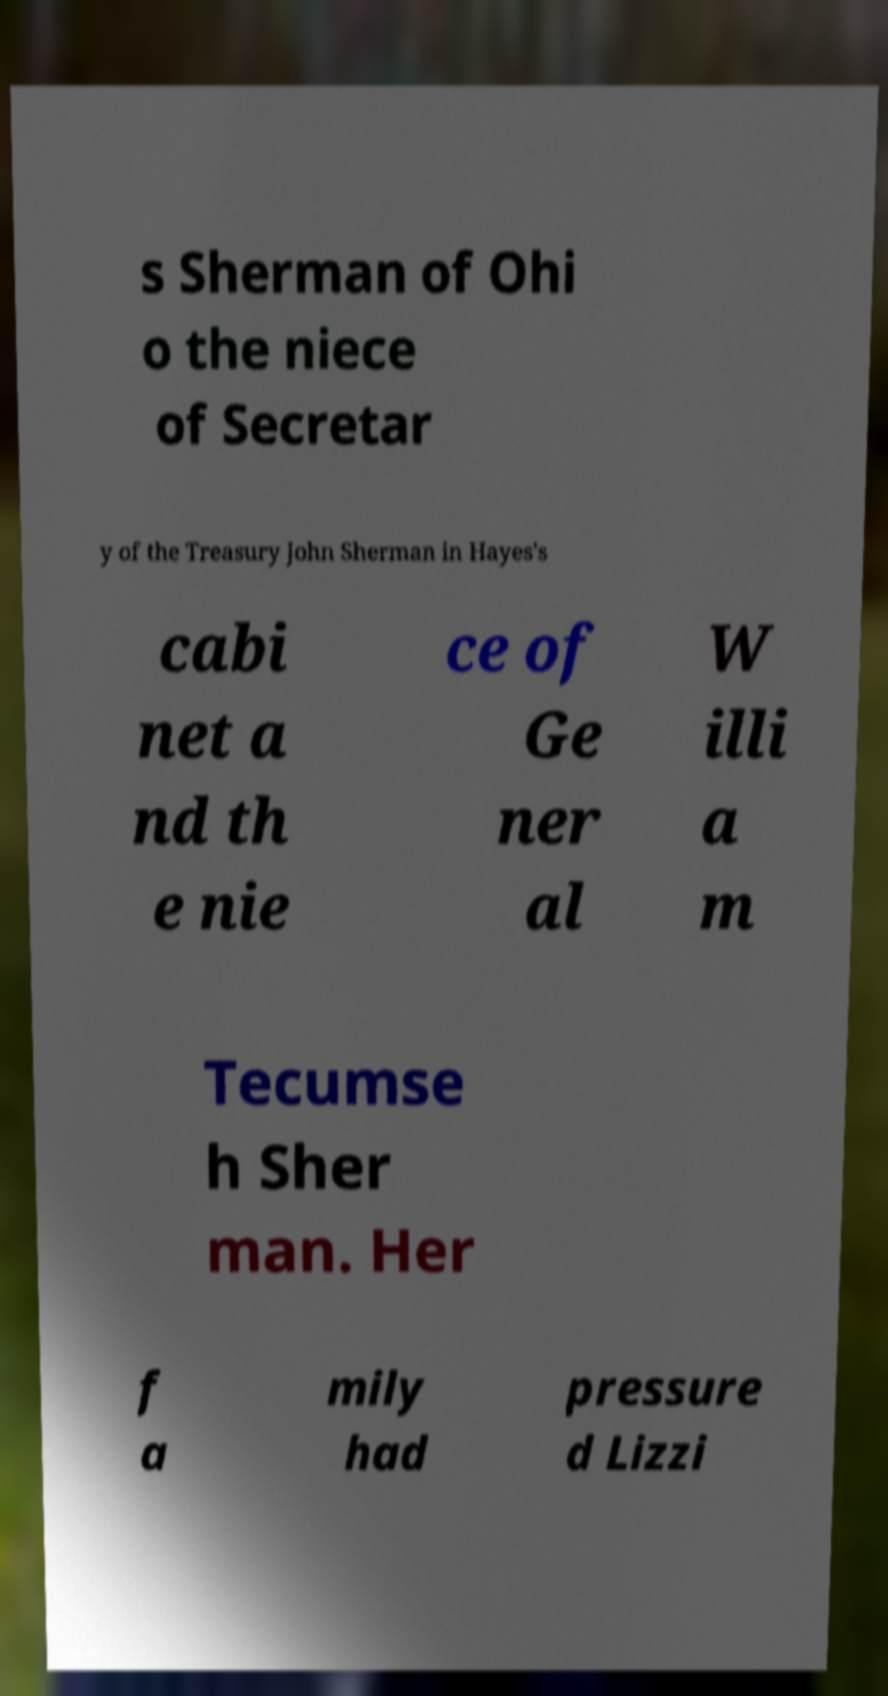Could you extract and type out the text from this image? s Sherman of Ohi o the niece of Secretar y of the Treasury John Sherman in Hayes's cabi net a nd th e nie ce of Ge ner al W illi a m Tecumse h Sher man. Her f a mily had pressure d Lizzi 